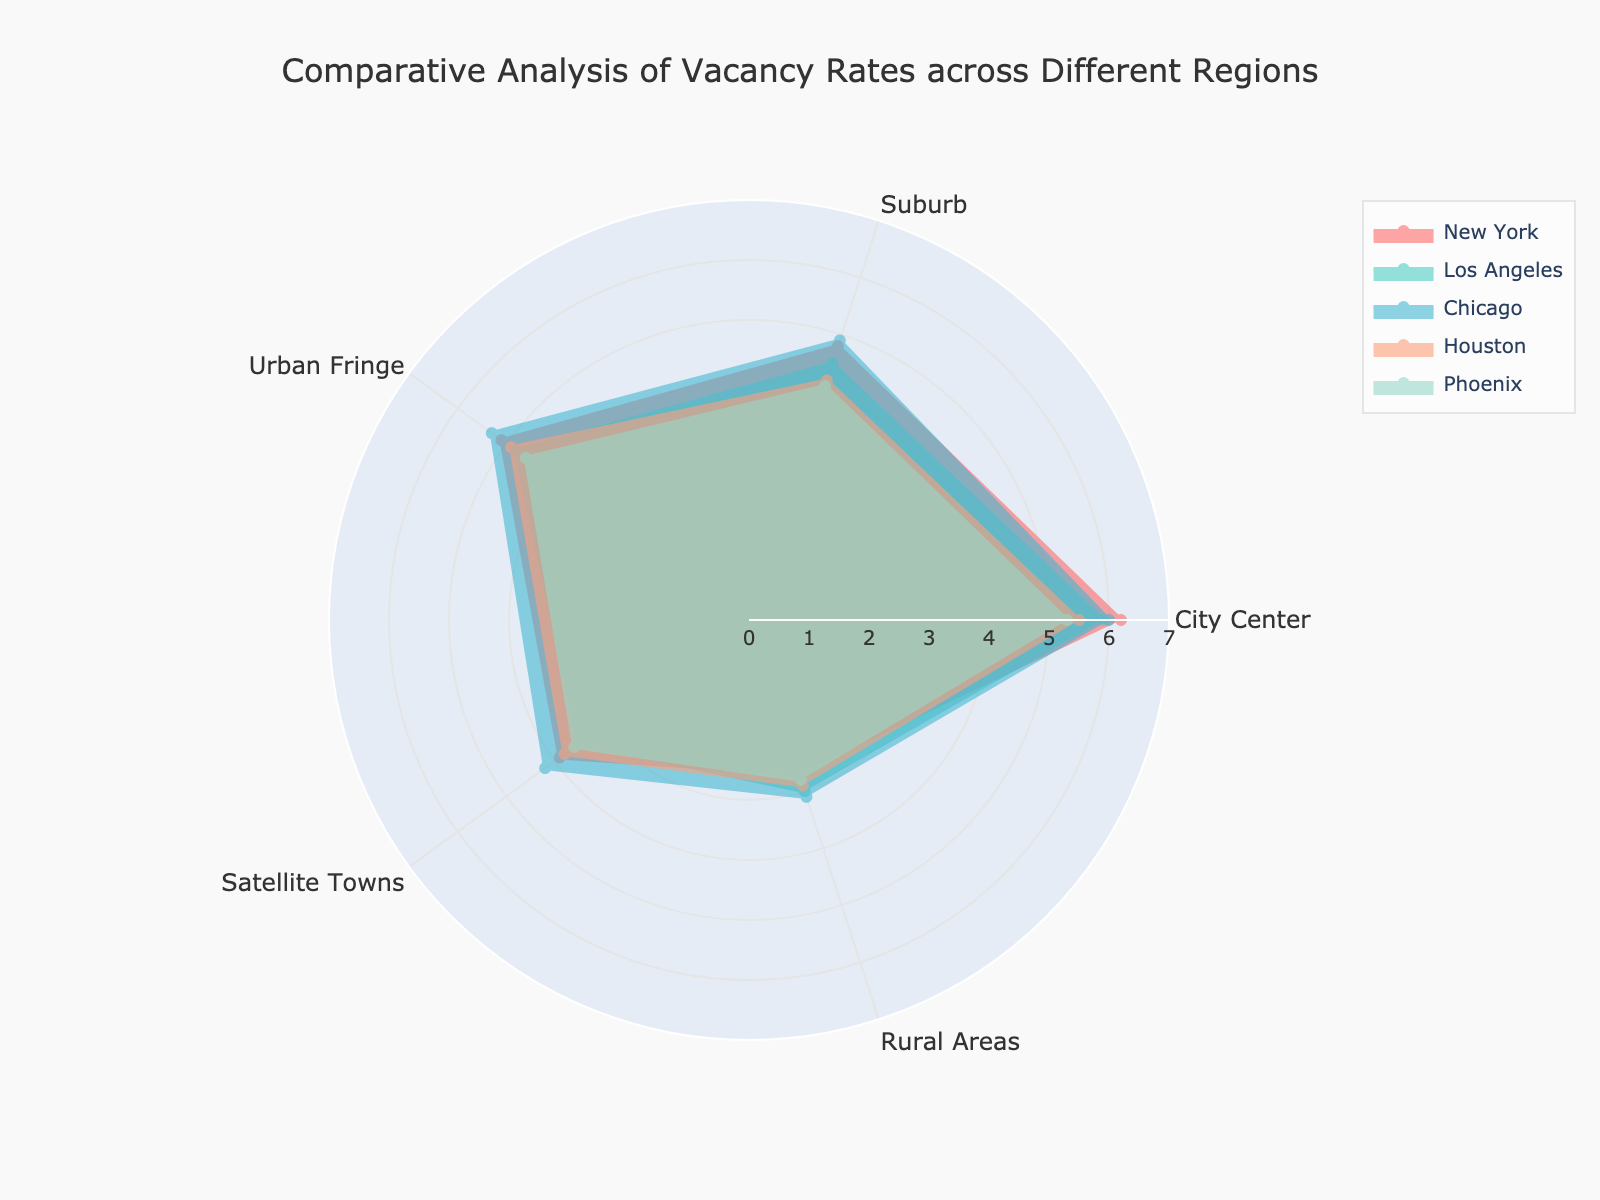what is the lowest vacancy rate among all regions? Look at the segments shown in the radar chart and identify which region has the lowest value among the five regions. Rural Areas in New York and Houston have the lowest value. The lowest vacancy rate is 2.7, corresponding to the Rural Areas segment of New York.
Answer: 2.7 Which region has the highest vacancy rate in the City Center? Look at the City Center segment for all regions and compare the values. New York has the highest value of 6.2.
Answer: New York What is the average vacancy rate in the Suburb area? Calculate the mean value for the Suburb area by summing the vacancy rates for all regions in this category and then dividing by the number of regions. (4.8 + 4.5 + 4.9 + 4.2 + 4.1) / 5 = 4.5
Answer: 4.5 Which region has the smallest difference in vacancy rates between City Center and Satellite Towns? Calculate the difference between the City Center and Satellite Towns rates for each region and find the smallest difference. New York: 6.2 - 3.9 = 2.3, Los Angeles: 5.9 - 3.5 = 2.4, Chicago: 6.0 - 4.2 = 1.8, Houston: 5.5 - 3.8 = 1.7, Phoenix: 5.3 - 3.6 = 1.7. Houston and Phoenix have the smallest difference of 1.7.
Answer: Houston & Phoenix Which area shows the most consistent vacancy rates across all regions? Look at the radar chart and see which area has the least variation in values relative to the others—compare the lengths of segments for consistency. The suburbs areas have similar values across all regions, with the least visible variation.
Answer: Suburb How do vacancy rates in Urban Fringe areas compare to Satellite Towns in Chicago? Observe the values in the Urban Fringe and Satellite Towns for Chicago. Urban Fringe: 5.3, Satellite Towns: 4.2. Urban Fringe rates are higher by 1.1.
Answer: Urban Fringe rates are higher In which region is the vacancy rate the highest in Rural Areas? Compare the vacancy rates in the Rural Areas segment for all regions. The highest value is 3.1 in Chicago.
Answer: Chicago What is the combined vacancy rate for City Center and Suburb in Houston? Add the vacancy rates for these two categories in Houston: 5.5 (City Center) + 4.2 (Suburb) = 9.7.
Answer: 9.7 